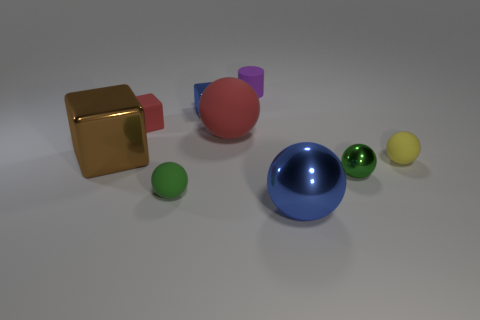The rubber ball that is the same color as the tiny rubber block is what size?
Provide a short and direct response. Large. What material is the large object that is the same color as the rubber block?
Ensure brevity in your answer.  Rubber. What is the material of the tiny green thing that is behind the small ball left of the blue ball that is in front of the small red cube?
Provide a short and direct response. Metal. How many other objects are there of the same color as the tiny cylinder?
Your response must be concise. 0. What number of red objects are rubber spheres or tiny things?
Ensure brevity in your answer.  2. There is a small green sphere that is on the left side of the large shiny ball; what material is it?
Your answer should be very brief. Rubber. Is the blue thing that is left of the tiny matte cylinder made of the same material as the brown object?
Your answer should be very brief. Yes. What is the shape of the large brown shiny object?
Your response must be concise. Cube. There is a yellow matte sphere that is on the right side of the big blue object in front of the brown object; how many small metallic things are on the left side of it?
Provide a succinct answer. 2. What number of other things are made of the same material as the large blue ball?
Your response must be concise. 3. 